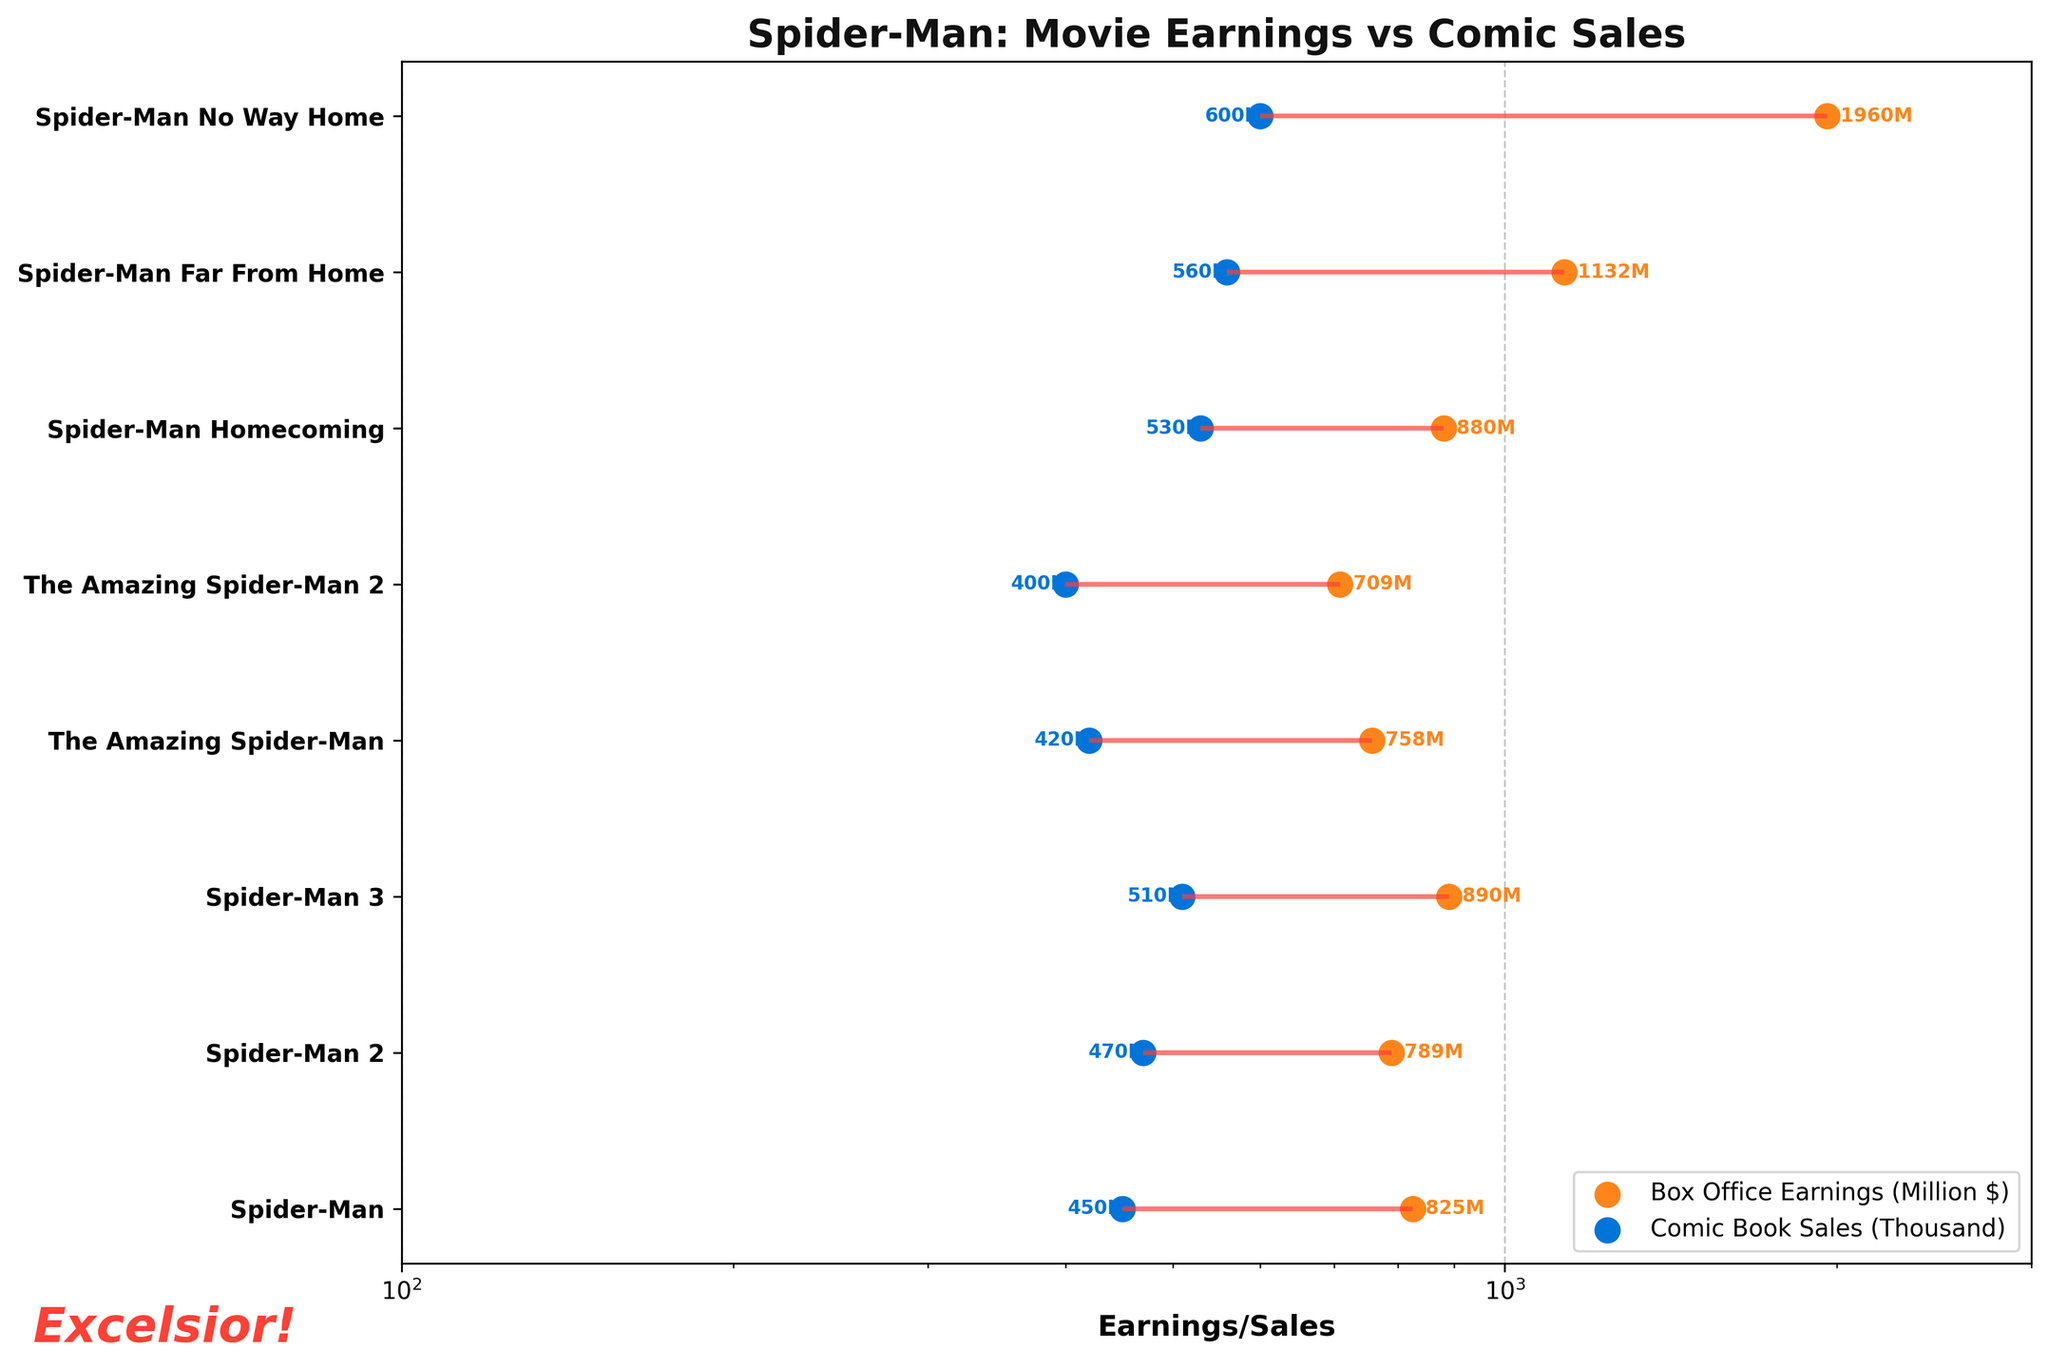How many movies are depicted in the plot? Count the number of distinct movies (dots) as labeled on the y-axis.
Answer: 8 What is the title of the figure? Read the text displayed as the title above the plot.
Answer: Spider-Man: Movie Earnings vs Comic Sales Which movie had the highest box office earnings? Identify the highest point on the x-axis among the box office earnings and match it to the movie on the y-axis.
Answer: Spider-Man No Way Home What is the range of comic book sales in thousands? Determine the minimum and maximum values on the x-axis for the comic book sales points. The minimum is 400K (The Amazing Spider-Man 2) and the maximum is 600K (Spider-Man No Way Home).
Answer: 400-600K Which movie is closest to having equal values for both box office earnings and comic book sales? Compare the lengths of the horizontal lines in the plot, finding the shortest line which indicates the values are closer.
Answer: Spider-Man Homecoming What is the color used for comic book sales dots? Identify the color of the dots representing comic book sales on the plot.
Answer: Blue In which year was the second highest total (box office + comic sales) recorded? Calculate the total for each year by adding box office earnings and comic book sales, and find the second highest value. Spider-Man Far From Home has a total of $1132M + 560K = 1692M+K, which is the second highest.
Answer: 2019 What is the difference in box office earnings between Spider-Man 3 and The Amazing Spider-Man 2? Subtract the box office earnings value of The Amazing Spider-Man 2 from that of Spider-Man 3.
Answer: 181M ($890M - $709M) Which two movies had the least difference between their comic book sales values? Calculate the absolute difference in comic book sales for each pair of movies, finding the smallest difference. Spider-Man 3 and Spider-Man Homecoming both have 530K and 510K, so the difference is 20K.
Answer: Spider-Man 3 and Spider-Man Homecoming Did any movie make more than $1 billion in box office earnings? Check the x-axis values for box office earnings and see if any exceed 1000M ($1 billion).
Answer: Yes 